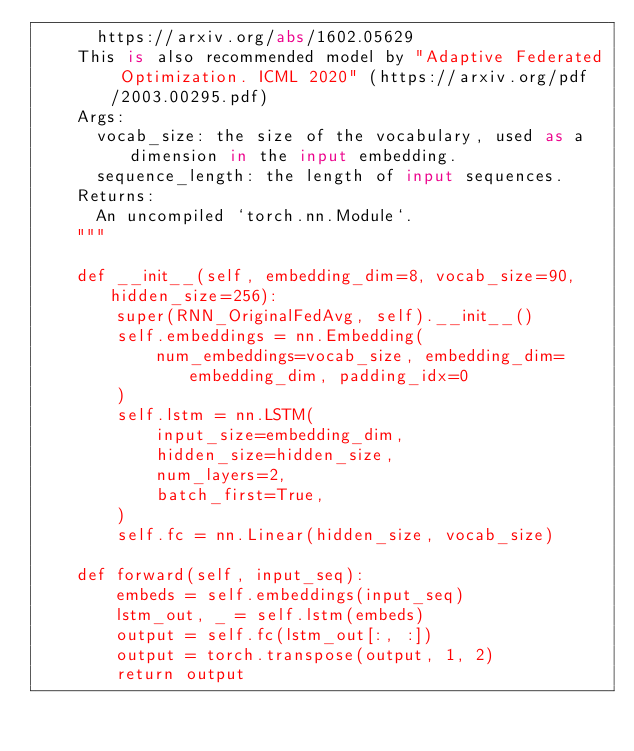<code> <loc_0><loc_0><loc_500><loc_500><_Python_>      https://arxiv.org/abs/1602.05629
    This is also recommended model by "Adaptive Federated Optimization. ICML 2020" (https://arxiv.org/pdf/2003.00295.pdf)
    Args:
      vocab_size: the size of the vocabulary, used as a dimension in the input embedding.
      sequence_length: the length of input sequences.
    Returns:
      An uncompiled `torch.nn.Module`.
    """

    def __init__(self, embedding_dim=8, vocab_size=90, hidden_size=256):
        super(RNN_OriginalFedAvg, self).__init__()
        self.embeddings = nn.Embedding(
            num_embeddings=vocab_size, embedding_dim=embedding_dim, padding_idx=0
        )
        self.lstm = nn.LSTM(
            input_size=embedding_dim,
            hidden_size=hidden_size,
            num_layers=2,
            batch_first=True,
        )
        self.fc = nn.Linear(hidden_size, vocab_size)

    def forward(self, input_seq):
        embeds = self.embeddings(input_seq)
        lstm_out, _ = self.lstm(embeds)
        output = self.fc(lstm_out[:, :])
        output = torch.transpose(output, 1, 2)
        return output
</code> 